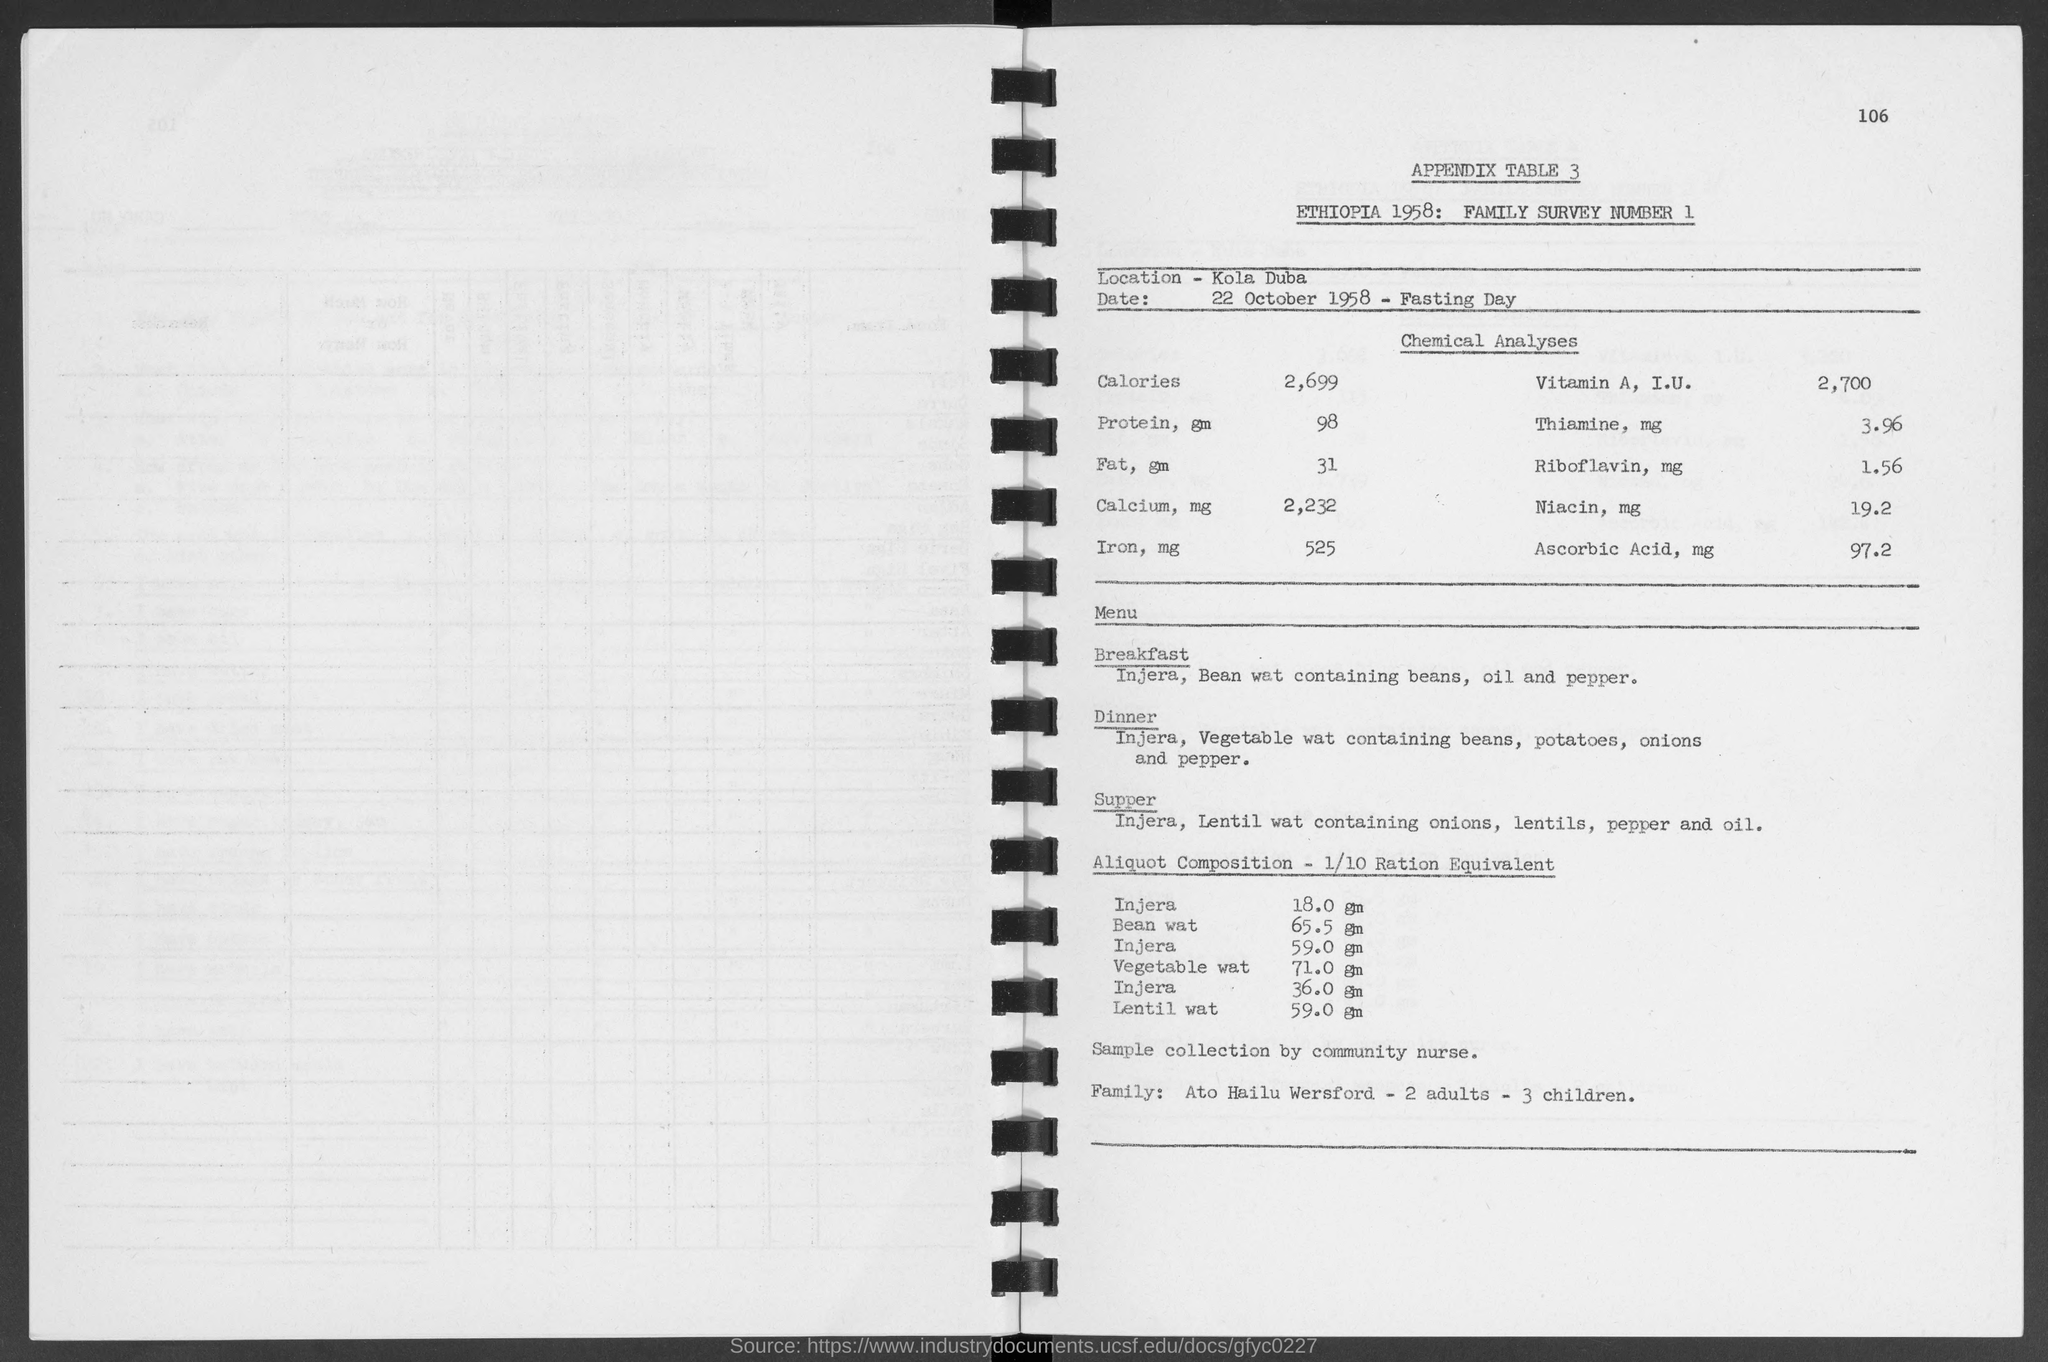What is the number at top-right corner of the page?
Offer a terse response. 106. What is the location ?
Keep it short and to the point. Kola Duba. What is the date below location ?
Provide a succinct answer. 22 October 1958. What is the appendix table no.?
Keep it short and to the point. 3. What is the family survey number ?
Ensure brevity in your answer.  1. What is the amount of lentil wat in aliquot composition - 1/10 ration equivalent ?
Your answer should be compact. 59.0 gm. What is the amount of bean wat in aliquot composition - 1/10 ration equivalent ?
Your answer should be compact. 65.5 gm. What is the amount of vegetable wat in aliquot composition - 1/10 ration equivalent ?
Your response must be concise. 71.0 gm. 